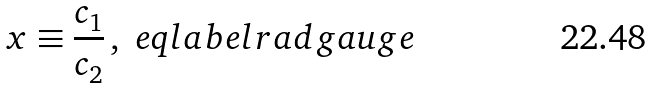<formula> <loc_0><loc_0><loc_500><loc_500>x \equiv \frac { c _ { 1 } } { c _ { 2 } } \, , \ e q l a b e l { r a d g a u g e }</formula> 